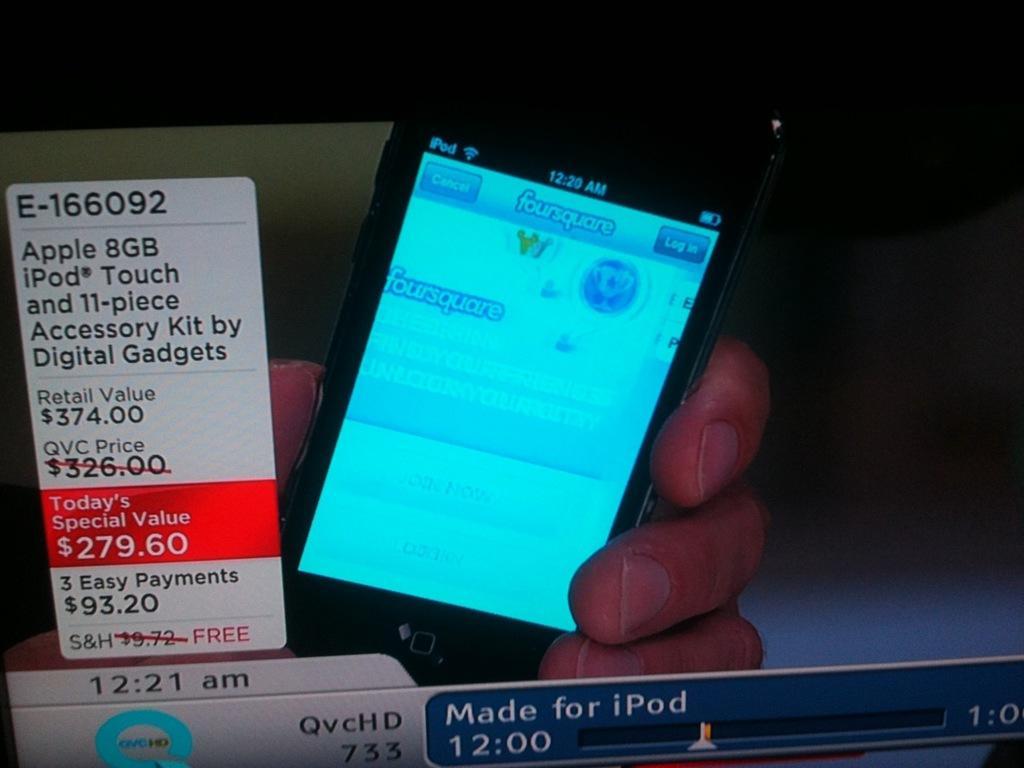How would you summarize this image in a sentence or two? In this image I can see the screen of a device. On the screen, I can see a person's hand holding a mobile. On the left side a paper is attached to the screen. On the paper there is some text and numbers. The background is blurred. 